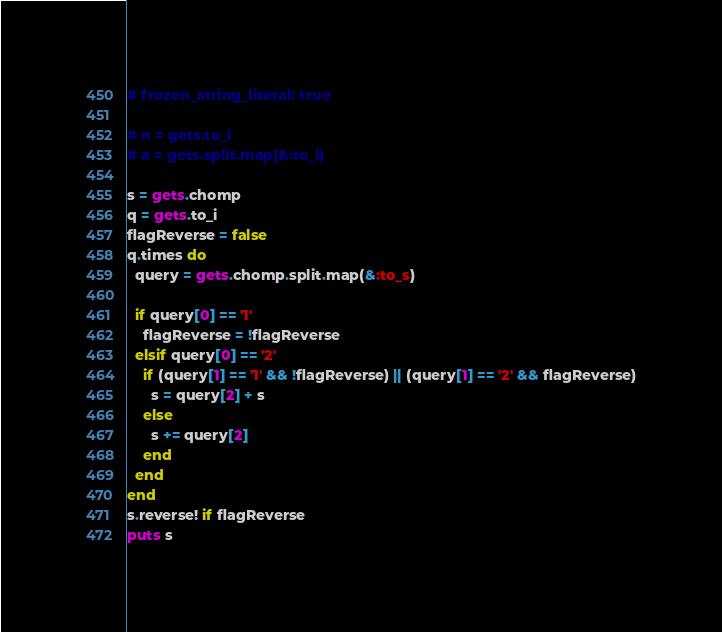<code> <loc_0><loc_0><loc_500><loc_500><_Ruby_># frozen_string_literal: true

# n = gets.to_i
# a = gets.split.map(&:to_i)

s = gets.chomp
q = gets.to_i
flagReverse = false
q.times do
  query = gets.chomp.split.map(&:to_s)

  if query[0] == '1'
    flagReverse = !flagReverse
  elsif query[0] == '2'
    if (query[1] == '1' && !flagReverse) || (query[1] == '2' && flagReverse)
      s = query[2] + s
    else
      s += query[2]
    end
  end
end
s.reverse! if flagReverse
puts s
</code> 